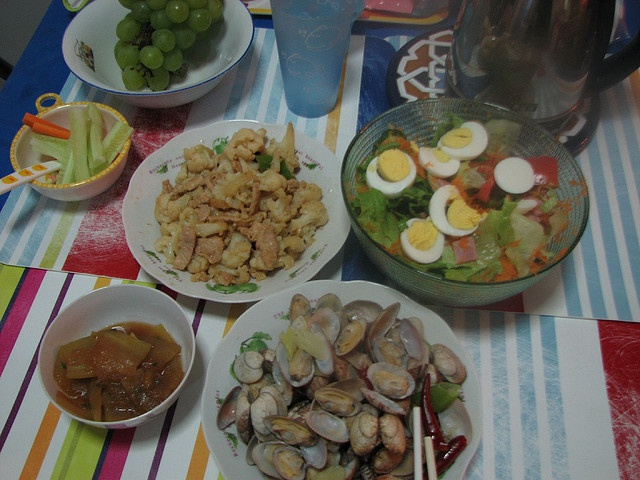Describe the objects in this image and their specific colors. I can see dining table in darkgray, gray, black, olive, and maroon tones, bowl in black, darkgreen, gray, and darkgray tones, bowl in black, maroon, and gray tones, bowl in black, gray, and darkgreen tones, and bowl in black, olive, and gray tones in this image. 